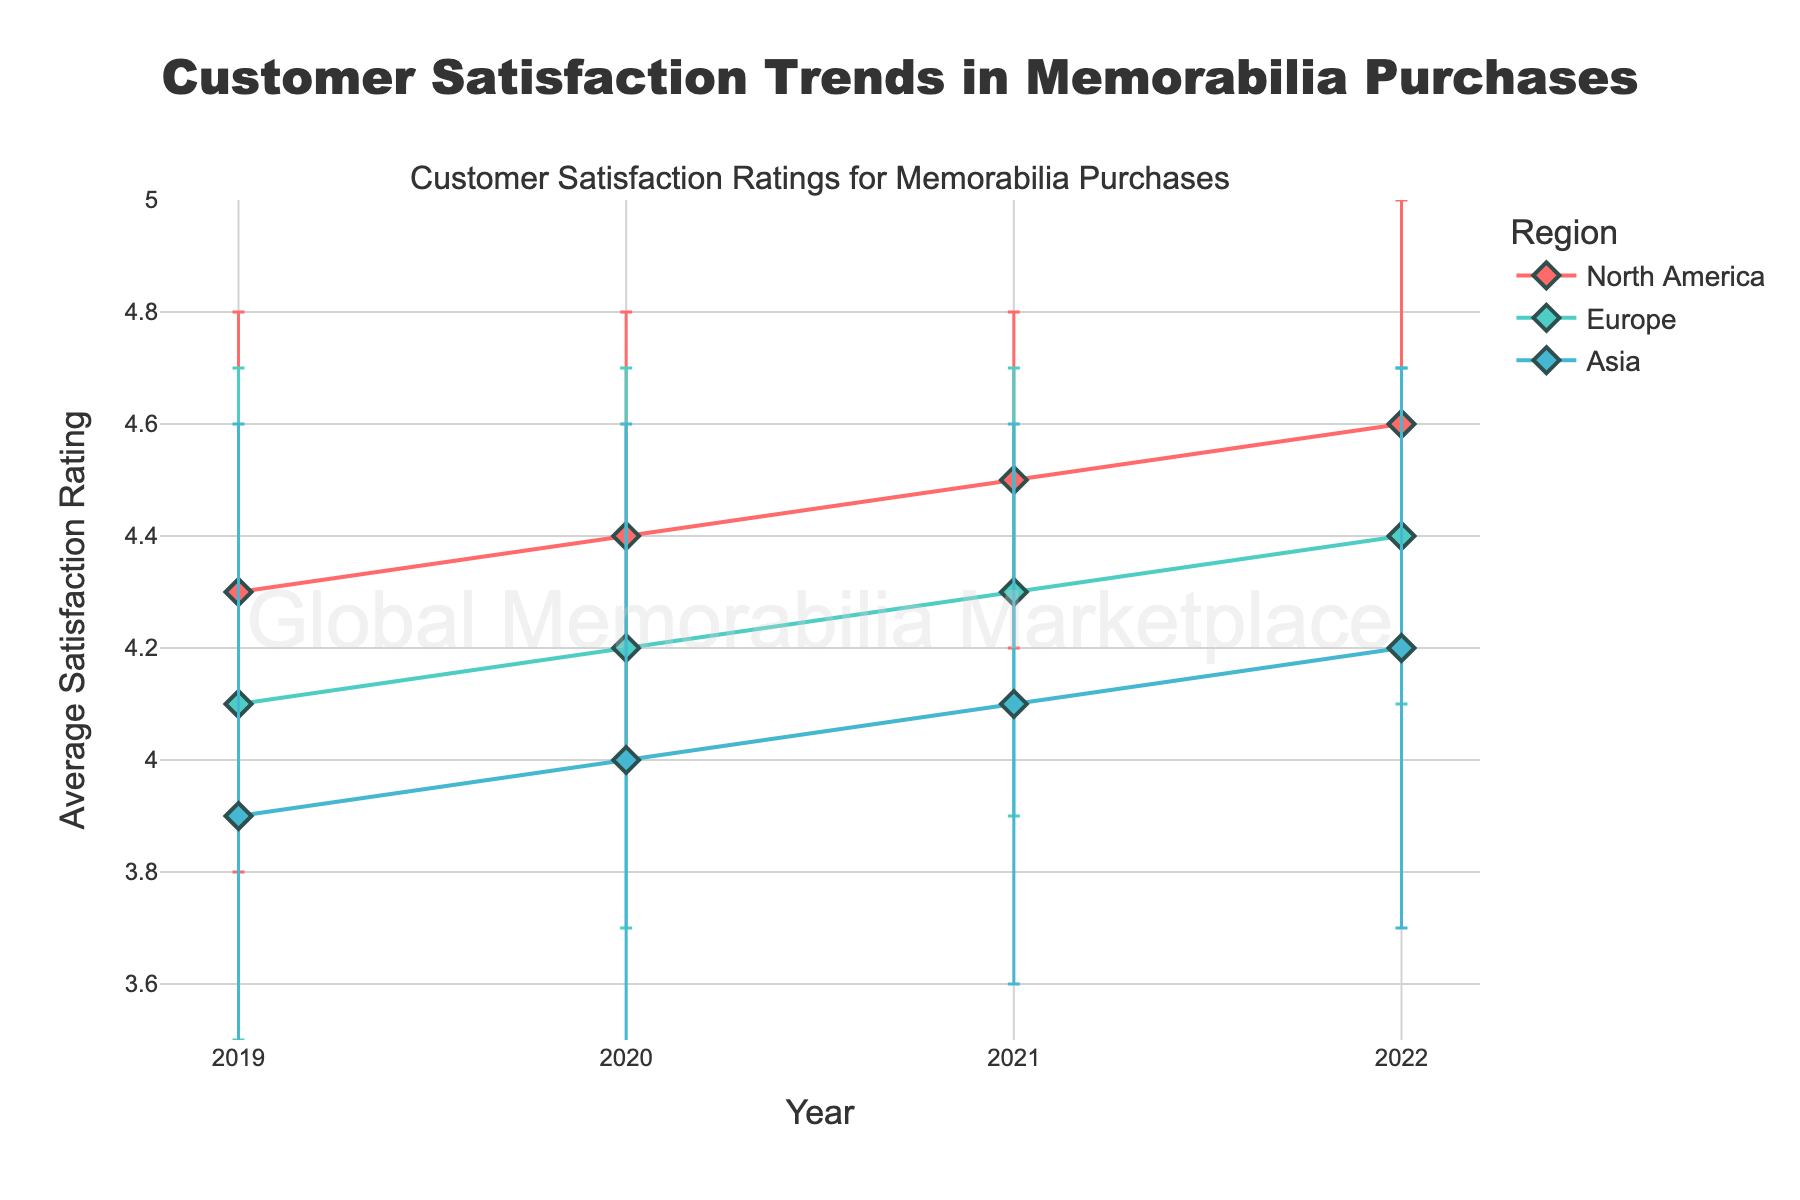Which year had the highest average satisfaction rating in North America? Look at the data points for North America across the years 2019, 2020, 2021, and 2022. The highest average is in 2022.
Answer: 2022 Which region had the lowest average satisfaction rating in 2019? Compare the average satisfaction ratings for North America, Europe, and Asia in 2019. Asia has the lowest rating.
Answer: Asia What is the average satisfaction rating for Europe in 2021? Identify the data point for Europe in 2021. The average satisfaction rating is shown directly.
Answer: 4.3 What is the difference in average satisfaction rating between 2019 and 2022 in Asia? Subtract the average satisfaction rating for Asia in 2019 from the rating in 2022. 4.2 - 3.9 = 0.3
Answer: 0.3 Which region showed the most improvement in customer satisfaction from 2019 to 2022? Calculate the difference in average satisfaction rating for each region between 2019 and 2022. North America improved from 4.3 to 4.6 (0.3), Europe from 4.1 to 4.4 (0.3), and Asia from 3.9 to 4.2 (0.3). All regions showed the same improvement.
Answer: All regions equally What is the range of average satisfaction ratings in 2020 across all regions? Find the minimum and maximum average satisfaction ratings for all regions in 2020. The range is the maximum minus the minimum (4.4 - 4.0 = 0.4).
Answer: 0.4 Which year had the smallest standard deviation for North America? Compare the standard deviations for North America across the years 2019, 2020, 2021, and 2022. The smallest standard deviation is in 2021.
Answer: 2021 In which year did Europe have a higher average satisfaction rating than Asia, but lower than North America? Compare the average satisfaction ratings for Europe, Asia, and North America across the years. In 2020, Europe (4.2) is higher than Asia (4.0) but lower than North America (4.4).
Answer: 2020 How does the trend of average satisfaction ratings for Asia compare to Europe from 2019 to 2022? Look at the overall movement of average satisfaction ratings for both Asia and Europe from 2019 to 2022. Both show an upward trend, but Europe starts higher and ends higher than Asia.
Answer: Both upward, Europe higher What is the standard deviation of customer satisfaction ratings in Asia in 2019? Identify the data point for the standard deviation in Asia in 2019. The standard deviation is shown directly.
Answer: 0.7 